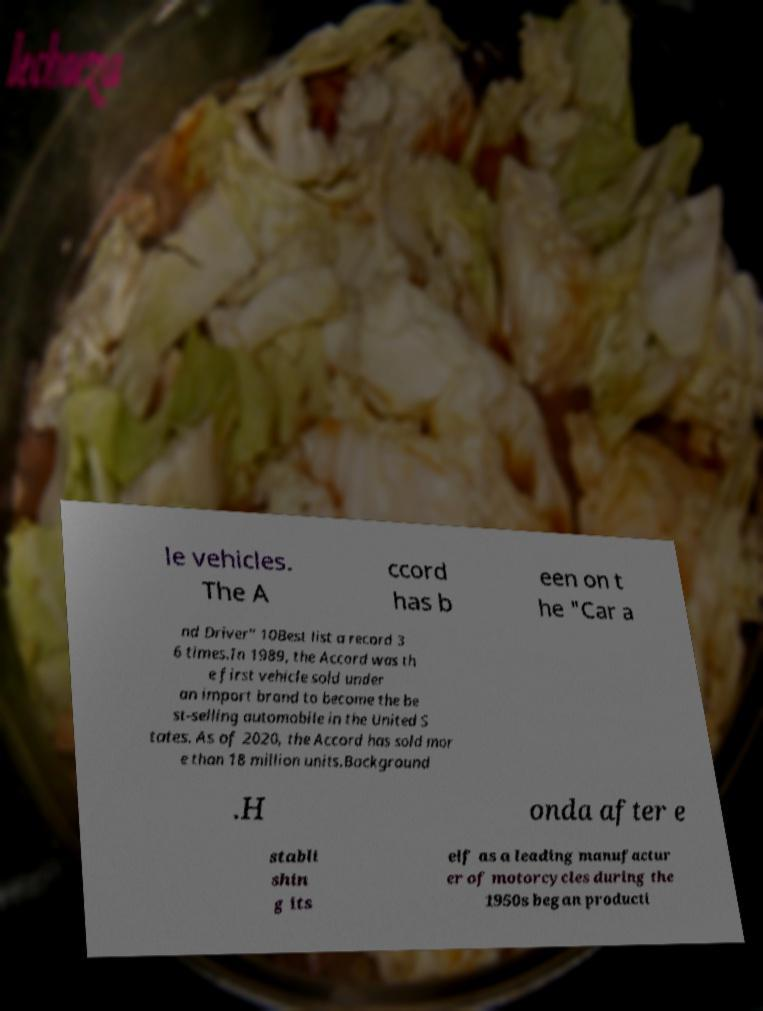Please identify and transcribe the text found in this image. le vehicles. The A ccord has b een on t he "Car a nd Driver" 10Best list a record 3 6 times.In 1989, the Accord was th e first vehicle sold under an import brand to become the be st-selling automobile in the United S tates. As of 2020, the Accord has sold mor e than 18 million units.Background .H onda after e stabli shin g its elf as a leading manufactur er of motorcycles during the 1950s began producti 